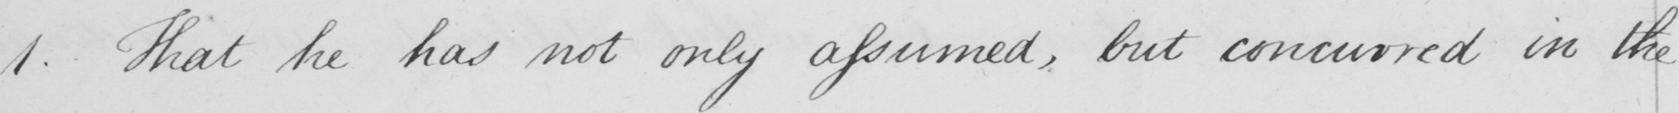Please provide the text content of this handwritten line. 1 . That he has not only assumed , but concurred in the 